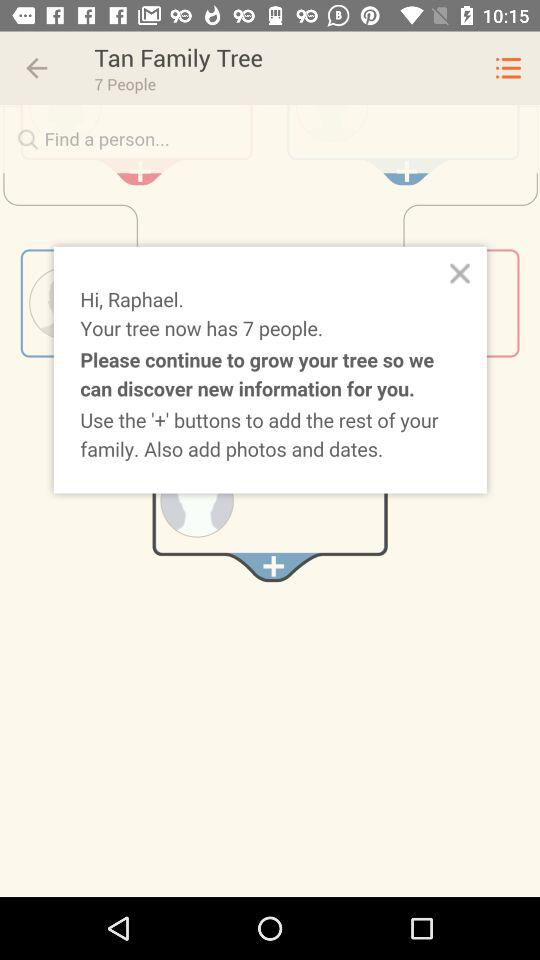What is the name of the tree? The name of the tree is "Tan Family". 